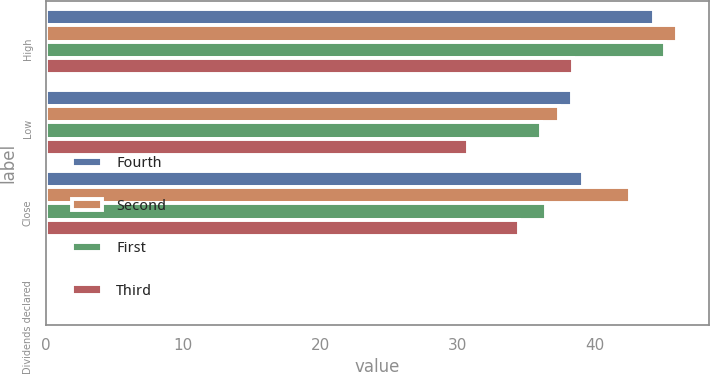Convert chart to OTSL. <chart><loc_0><loc_0><loc_500><loc_500><stacked_bar_chart><ecel><fcel>High<fcel>Low<fcel>Close<fcel>Dividends declared<nl><fcel>Fourth<fcel>44.32<fcel>38.39<fcel>39.14<fcel>0.13<nl><fcel>Second<fcel>46.03<fcel>37.45<fcel>42.62<fcel>0.13<nl><fcel>First<fcel>45.17<fcel>36.11<fcel>36.5<fcel>0.13<nl><fcel>Third<fcel>38.41<fcel>30.8<fcel>34.52<fcel>0.13<nl></chart> 